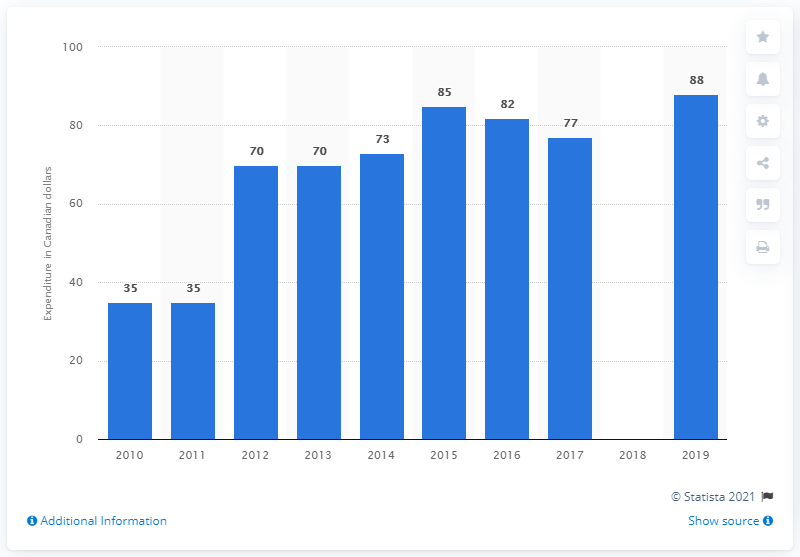List a handful of essential elements in this visual. In Canada in 2019, the average annual expenditure on chocolate bars was approximately CAD 88 per person. 